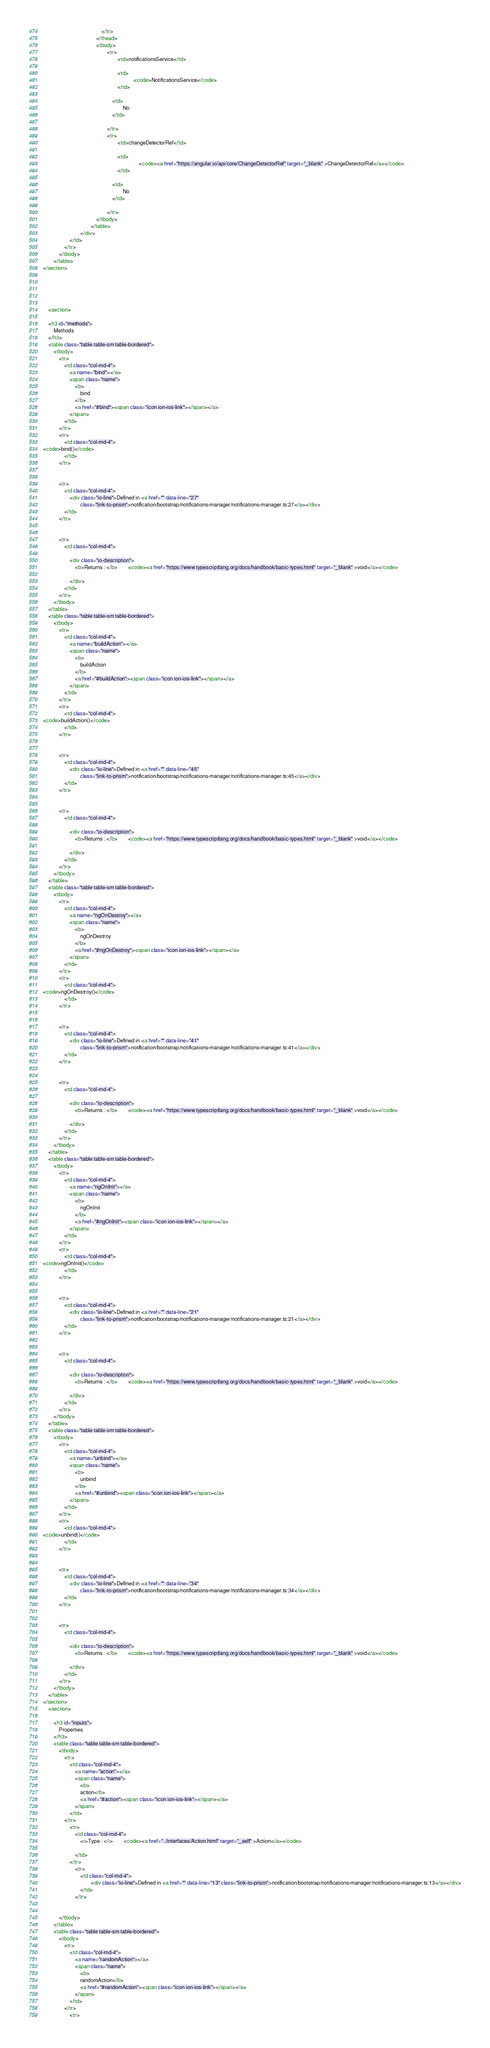Convert code to text. <code><loc_0><loc_0><loc_500><loc_500><_HTML_>                                            </tr>
                                        </thead>
                                        <tbody>
                                                <tr>
                                                        <td>notificationsService</td>
                                                  
                                                        <td>
                                                                    <code>NotificationsService</code>
                                                        </td>
                                                  
                                                    <td>
                                                            No
                                                    </td>
                                                    
                                                </tr>
                                                <tr>
                                                        <td>changeDetectorRef</td>
                                                  
                                                        <td>
                                                                        <code><a href="https://angular.io/api/core/ChangeDetectorRef" target="_blank" >ChangeDetectorRef</a></code>
                                                        </td>
                                                  
                                                    <td>
                                                            No
                                                    </td>
                                                    
                                                </tr>
                                        </tbody>
                                    </table>
                            </div>
                    </td>
                </tr>
            </tbody>
        </table>
</section>





    <section>
    
    <h3 id="methods">
        Methods
    </h3>
    <table class="table table-sm table-bordered">
        <tbody>
            <tr>
                <td class="col-md-4">
                    <a name="bind"></a>
                    <span class="name">
                        <b>
                            bind
                        </b>
                        <a href="#bind"><span class="icon ion-ios-link"></span></a>
                    </span>
                </td>
            </tr>
            <tr>
                <td class="col-md-4">
<code>bind()</code>
                </td>
            </tr>


            <tr>
                <td class="col-md-4">
                    <div class="io-line">Defined in <a href="" data-line="27"
                            class="link-to-prism">notification/bootstrap/notifications-manager/notifications-manager.ts:27</a></div>
                </td>
            </tr>


            <tr>
                <td class="col-md-4">

                    <div class="io-description">
                        <b>Returns : </b>        <code><a href="https://www.typescriptlang.org/docs/handbook/basic-types.html" target="_blank" >void</a></code>

                    </div>
                </td>
            </tr>
        </tbody>
    </table>
    <table class="table table-sm table-bordered">
        <tbody>
            <tr>
                <td class="col-md-4">
                    <a name="buildAction"></a>
                    <span class="name">
                        <b>
                            buildAction
                        </b>
                        <a href="#buildAction"><span class="icon ion-ios-link"></span></a>
                    </span>
                </td>
            </tr>
            <tr>
                <td class="col-md-4">
<code>buildAction()</code>
                </td>
            </tr>


            <tr>
                <td class="col-md-4">
                    <div class="io-line">Defined in <a href="" data-line="45"
                            class="link-to-prism">notification/bootstrap/notifications-manager/notifications-manager.ts:45</a></div>
                </td>
            </tr>


            <tr>
                <td class="col-md-4">

                    <div class="io-description">
                        <b>Returns : </b>        <code><a href="https://www.typescriptlang.org/docs/handbook/basic-types.html" target="_blank" >void</a></code>

                    </div>
                </td>
            </tr>
        </tbody>
    </table>
    <table class="table table-sm table-bordered">
        <tbody>
            <tr>
                <td class="col-md-4">
                    <a name="ngOnDestroy"></a>
                    <span class="name">
                        <b>
                            ngOnDestroy
                        </b>
                        <a href="#ngOnDestroy"><span class="icon ion-ios-link"></span></a>
                    </span>
                </td>
            </tr>
            <tr>
                <td class="col-md-4">
<code>ngOnDestroy()</code>
                </td>
            </tr>


            <tr>
                <td class="col-md-4">
                    <div class="io-line">Defined in <a href="" data-line="41"
                            class="link-to-prism">notification/bootstrap/notifications-manager/notifications-manager.ts:41</a></div>
                </td>
            </tr>


            <tr>
                <td class="col-md-4">

                    <div class="io-description">
                        <b>Returns : </b>        <code><a href="https://www.typescriptlang.org/docs/handbook/basic-types.html" target="_blank" >void</a></code>

                    </div>
                </td>
            </tr>
        </tbody>
    </table>
    <table class="table table-sm table-bordered">
        <tbody>
            <tr>
                <td class="col-md-4">
                    <a name="ngOnInit"></a>
                    <span class="name">
                        <b>
                            ngOnInit
                        </b>
                        <a href="#ngOnInit"><span class="icon ion-ios-link"></span></a>
                    </span>
                </td>
            </tr>
            <tr>
                <td class="col-md-4">
<code>ngOnInit()</code>
                </td>
            </tr>


            <tr>
                <td class="col-md-4">
                    <div class="io-line">Defined in <a href="" data-line="21"
                            class="link-to-prism">notification/bootstrap/notifications-manager/notifications-manager.ts:21</a></div>
                </td>
            </tr>


            <tr>
                <td class="col-md-4">

                    <div class="io-description">
                        <b>Returns : </b>        <code><a href="https://www.typescriptlang.org/docs/handbook/basic-types.html" target="_blank" >void</a></code>

                    </div>
                </td>
            </tr>
        </tbody>
    </table>
    <table class="table table-sm table-bordered">
        <tbody>
            <tr>
                <td class="col-md-4">
                    <a name="unbind"></a>
                    <span class="name">
                        <b>
                            unbind
                        </b>
                        <a href="#unbind"><span class="icon ion-ios-link"></span></a>
                    </span>
                </td>
            </tr>
            <tr>
                <td class="col-md-4">
<code>unbind()</code>
                </td>
            </tr>


            <tr>
                <td class="col-md-4">
                    <div class="io-line">Defined in <a href="" data-line="34"
                            class="link-to-prism">notification/bootstrap/notifications-manager/notifications-manager.ts:34</a></div>
                </td>
            </tr>


            <tr>
                <td class="col-md-4">

                    <div class="io-description">
                        <b>Returns : </b>        <code><a href="https://www.typescriptlang.org/docs/handbook/basic-types.html" target="_blank" >void</a></code>

                    </div>
                </td>
            </tr>
        </tbody>
    </table>
</section>
    <section>
    
        <h3 id="inputs">
            Properties
        </h3>
        <table class="table table-sm table-bordered">
            <tbody>
                <tr>
                    <td class="col-md-4">
                        <a name="action"></a>
                        <span class="name">
                            <b>
                            action</b>
                            <a href="#action"><span class="icon ion-ios-link"></span></a>
                        </span>
                    </td>
                </tr>
                    <tr>
                        <td class="col-md-4">
                            <i>Type : </i>        <code><a href="../interfaces/Action.html" target="_self" >Action</a></code>

                        </td>
                    </tr>
                        <tr>
                            <td class="col-md-4">
                                    <div class="io-line">Defined in <a href="" data-line="13" class="link-to-prism">notification/bootstrap/notifications-manager/notifications-manager.ts:13</a></div>
                            </td>
                        </tr>


            </tbody>
        </table>
        <table class="table table-sm table-bordered">
            <tbody>
                <tr>
                    <td class="col-md-4">
                        <a name="randomAction"></a>
                        <span class="name">
                            <b>
                            randomAction</b>
                            <a href="#randomAction"><span class="icon ion-ios-link"></span></a>
                        </span>
                    </td>
                </tr>
                    <tr></code> 